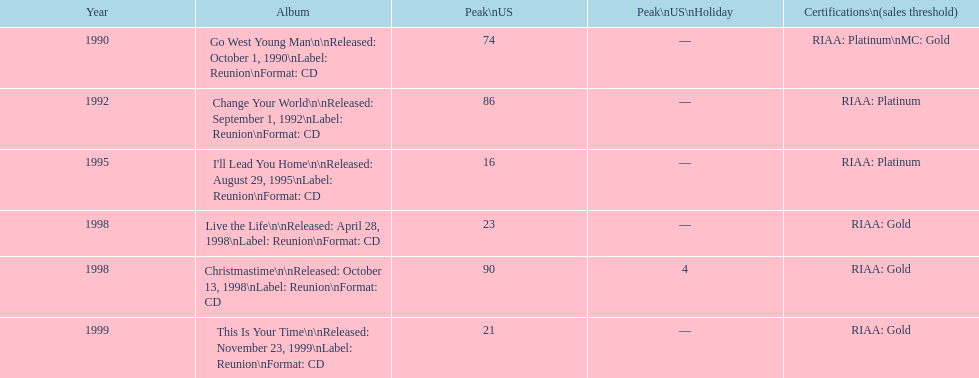Help me parse the entirety of this table. {'header': ['Year', 'Album', 'Peak\\nUS', 'Peak\\nUS\\nHoliday', 'Certifications\\n(sales threshold)'], 'rows': [['1990', 'Go West Young Man\\n\\nReleased: October 1, 1990\\nLabel: Reunion\\nFormat: CD', '74', '—', 'RIAA: Platinum\\nMC: Gold'], ['1992', 'Change Your World\\n\\nReleased: September 1, 1992\\nLabel: Reunion\\nFormat: CD', '86', '—', 'RIAA: Platinum'], ['1995', "I'll Lead You Home\\n\\nReleased: August 29, 1995\\nLabel: Reunion\\nFormat: CD", '16', '—', 'RIAA: Platinum'], ['1998', 'Live the Life\\n\\nReleased: April 28, 1998\\nLabel: Reunion\\nFormat: CD', '23', '—', 'RIAA: Gold'], ['1998', 'Christmastime\\n\\nReleased: October 13, 1998\\nLabel: Reunion\\nFormat: CD', '90', '4', 'RIAA: Gold'], ['1999', 'This Is Your Time\\n\\nReleased: November 23, 1999\\nLabel: Reunion\\nFormat: CD', '21', '—', 'RIAA: Gold']]} What is the count of album entries? 6. 